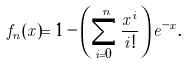Convert formula to latex. <formula><loc_0><loc_0><loc_500><loc_500>f _ { n } ( x ) = 1 - \left ( \sum _ { i = 0 } ^ { n } \frac { x ^ { i } } { i ! } \right ) e ^ { - x } .</formula> 